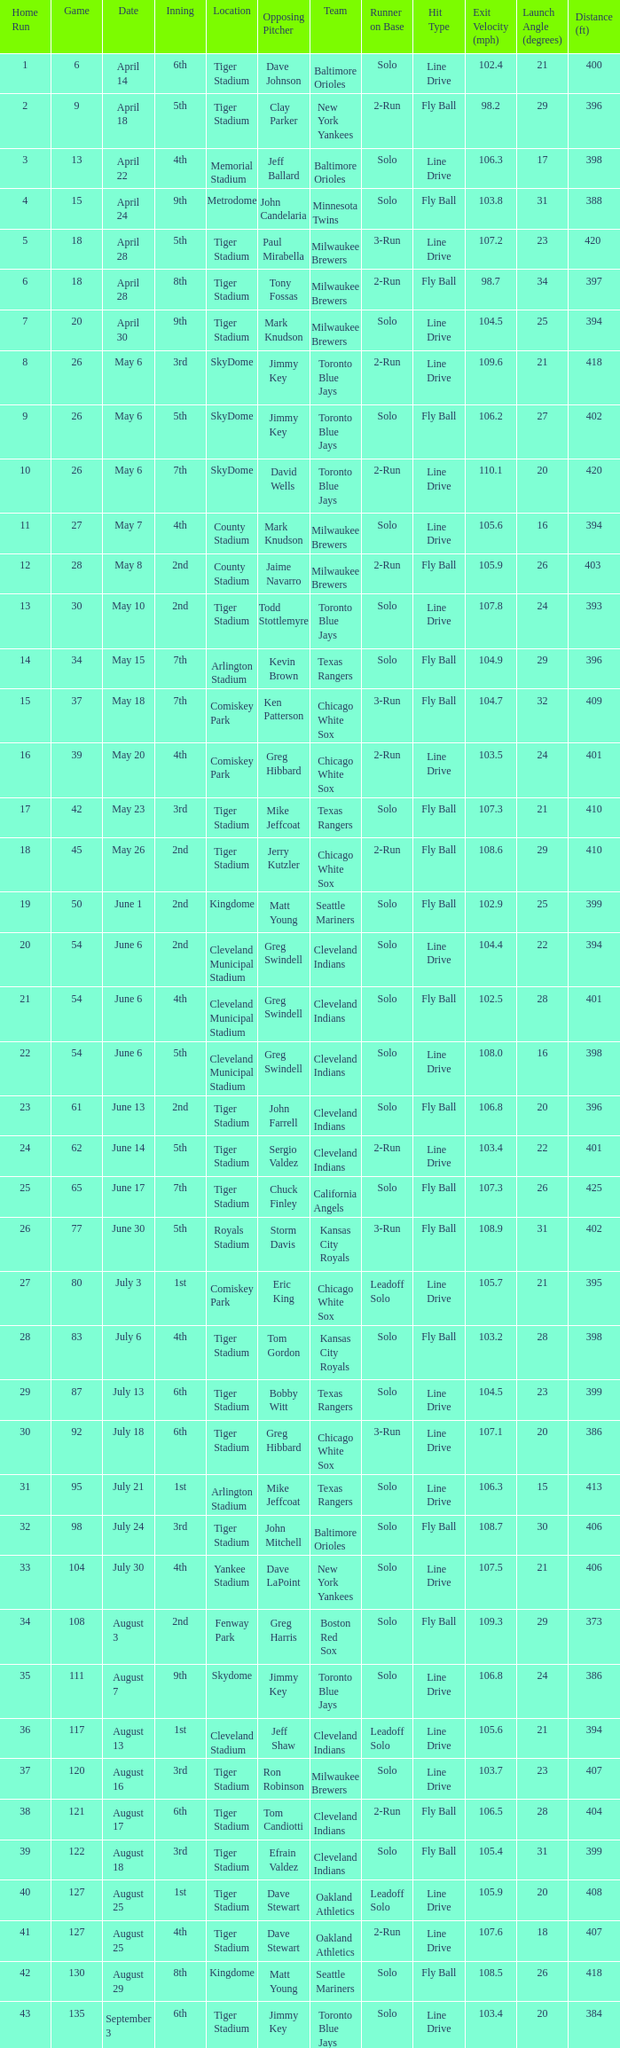On June 17 in Tiger stadium, what was the average home run? 25.0. 